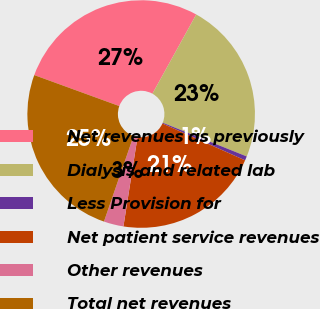Convert chart to OTSL. <chart><loc_0><loc_0><loc_500><loc_500><pie_chart><fcel>Net revenues as previously<fcel>Dialysis and related lab<fcel>Less Provision for<fcel>Net patient service revenues<fcel>Other revenues<fcel>Total net revenues<nl><fcel>27.48%<fcel>23.04%<fcel>0.59%<fcel>20.82%<fcel>2.81%<fcel>25.26%<nl></chart> 